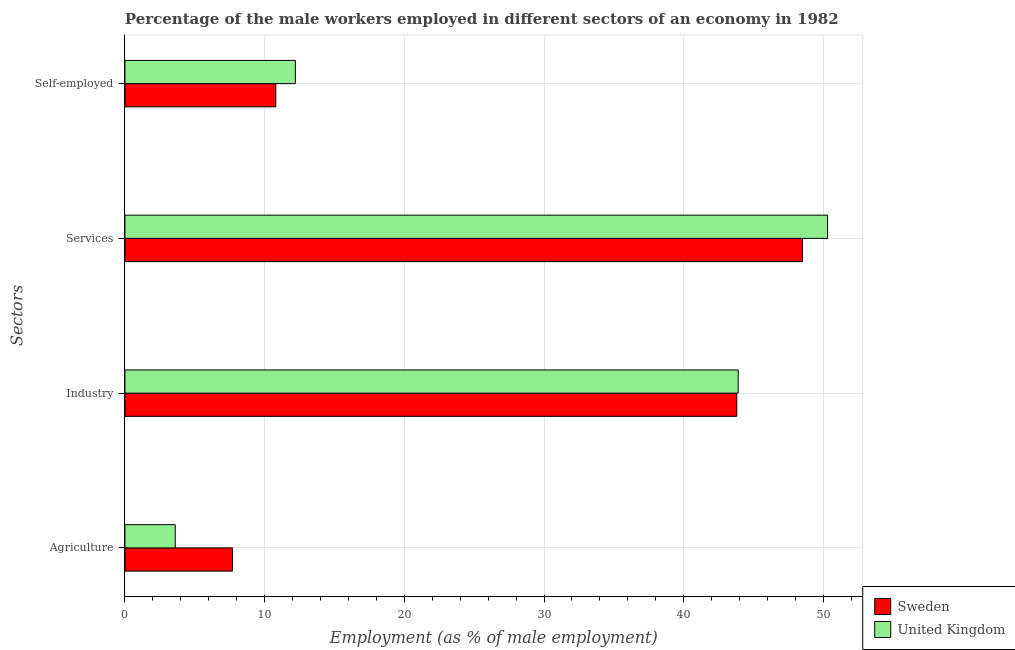How many different coloured bars are there?
Provide a short and direct response. 2. Are the number of bars per tick equal to the number of legend labels?
Your answer should be compact. Yes. Are the number of bars on each tick of the Y-axis equal?
Your answer should be compact. Yes. How many bars are there on the 4th tick from the top?
Provide a succinct answer. 2. What is the label of the 4th group of bars from the top?
Make the answer very short. Agriculture. What is the percentage of self employed male workers in Sweden?
Provide a short and direct response. 10.8. Across all countries, what is the maximum percentage of male workers in services?
Your answer should be very brief. 50.3. Across all countries, what is the minimum percentage of male workers in agriculture?
Offer a very short reply. 3.6. In which country was the percentage of male workers in services minimum?
Your answer should be compact. Sweden. What is the total percentage of self employed male workers in the graph?
Provide a short and direct response. 23. What is the difference between the percentage of self employed male workers in United Kingdom and that in Sweden?
Make the answer very short. 1.4. What is the difference between the percentage of self employed male workers in United Kingdom and the percentage of male workers in agriculture in Sweden?
Your answer should be very brief. 4.5. What is the average percentage of male workers in agriculture per country?
Make the answer very short. 5.65. What is the difference between the percentage of male workers in industry and percentage of self employed male workers in Sweden?
Offer a terse response. 33. In how many countries, is the percentage of male workers in industry greater than 26 %?
Keep it short and to the point. 2. What is the ratio of the percentage of male workers in industry in United Kingdom to that in Sweden?
Give a very brief answer. 1. Is the difference between the percentage of male workers in industry in United Kingdom and Sweden greater than the difference between the percentage of self employed male workers in United Kingdom and Sweden?
Ensure brevity in your answer.  No. What is the difference between the highest and the second highest percentage of male workers in services?
Provide a short and direct response. 1.8. What is the difference between the highest and the lowest percentage of male workers in industry?
Ensure brevity in your answer.  0.1. In how many countries, is the percentage of male workers in industry greater than the average percentage of male workers in industry taken over all countries?
Your answer should be compact. 1. What does the 1st bar from the top in Agriculture represents?
Offer a terse response. United Kingdom. What does the 2nd bar from the bottom in Agriculture represents?
Your answer should be very brief. United Kingdom. Is it the case that in every country, the sum of the percentage of male workers in agriculture and percentage of male workers in industry is greater than the percentage of male workers in services?
Your response must be concise. No. Are all the bars in the graph horizontal?
Offer a terse response. Yes. Are the values on the major ticks of X-axis written in scientific E-notation?
Offer a terse response. No. Does the graph contain any zero values?
Your answer should be compact. No. Does the graph contain grids?
Provide a succinct answer. Yes. What is the title of the graph?
Provide a succinct answer. Percentage of the male workers employed in different sectors of an economy in 1982. What is the label or title of the X-axis?
Your answer should be compact. Employment (as % of male employment). What is the label or title of the Y-axis?
Provide a short and direct response. Sectors. What is the Employment (as % of male employment) of Sweden in Agriculture?
Your answer should be compact. 7.7. What is the Employment (as % of male employment) of United Kingdom in Agriculture?
Make the answer very short. 3.6. What is the Employment (as % of male employment) of Sweden in Industry?
Ensure brevity in your answer.  43.8. What is the Employment (as % of male employment) in United Kingdom in Industry?
Offer a very short reply. 43.9. What is the Employment (as % of male employment) in Sweden in Services?
Provide a short and direct response. 48.5. What is the Employment (as % of male employment) in United Kingdom in Services?
Your answer should be compact. 50.3. What is the Employment (as % of male employment) in Sweden in Self-employed?
Offer a very short reply. 10.8. What is the Employment (as % of male employment) in United Kingdom in Self-employed?
Make the answer very short. 12.2. Across all Sectors, what is the maximum Employment (as % of male employment) in Sweden?
Make the answer very short. 48.5. Across all Sectors, what is the maximum Employment (as % of male employment) in United Kingdom?
Make the answer very short. 50.3. Across all Sectors, what is the minimum Employment (as % of male employment) in Sweden?
Provide a short and direct response. 7.7. Across all Sectors, what is the minimum Employment (as % of male employment) of United Kingdom?
Your answer should be very brief. 3.6. What is the total Employment (as % of male employment) in Sweden in the graph?
Make the answer very short. 110.8. What is the total Employment (as % of male employment) in United Kingdom in the graph?
Ensure brevity in your answer.  110. What is the difference between the Employment (as % of male employment) of Sweden in Agriculture and that in Industry?
Your answer should be very brief. -36.1. What is the difference between the Employment (as % of male employment) of United Kingdom in Agriculture and that in Industry?
Your response must be concise. -40.3. What is the difference between the Employment (as % of male employment) of Sweden in Agriculture and that in Services?
Your response must be concise. -40.8. What is the difference between the Employment (as % of male employment) in United Kingdom in Agriculture and that in Services?
Your answer should be compact. -46.7. What is the difference between the Employment (as % of male employment) in Sweden in Agriculture and that in Self-employed?
Your response must be concise. -3.1. What is the difference between the Employment (as % of male employment) in Sweden in Industry and that in Self-employed?
Offer a terse response. 33. What is the difference between the Employment (as % of male employment) in United Kingdom in Industry and that in Self-employed?
Keep it short and to the point. 31.7. What is the difference between the Employment (as % of male employment) in Sweden in Services and that in Self-employed?
Offer a very short reply. 37.7. What is the difference between the Employment (as % of male employment) in United Kingdom in Services and that in Self-employed?
Provide a short and direct response. 38.1. What is the difference between the Employment (as % of male employment) of Sweden in Agriculture and the Employment (as % of male employment) of United Kingdom in Industry?
Keep it short and to the point. -36.2. What is the difference between the Employment (as % of male employment) of Sweden in Agriculture and the Employment (as % of male employment) of United Kingdom in Services?
Your response must be concise. -42.6. What is the difference between the Employment (as % of male employment) of Sweden in Industry and the Employment (as % of male employment) of United Kingdom in Services?
Ensure brevity in your answer.  -6.5. What is the difference between the Employment (as % of male employment) of Sweden in Industry and the Employment (as % of male employment) of United Kingdom in Self-employed?
Offer a very short reply. 31.6. What is the difference between the Employment (as % of male employment) in Sweden in Services and the Employment (as % of male employment) in United Kingdom in Self-employed?
Offer a very short reply. 36.3. What is the average Employment (as % of male employment) in Sweden per Sectors?
Provide a short and direct response. 27.7. What is the average Employment (as % of male employment) in United Kingdom per Sectors?
Offer a terse response. 27.5. What is the difference between the Employment (as % of male employment) in Sweden and Employment (as % of male employment) in United Kingdom in Services?
Offer a very short reply. -1.8. What is the difference between the Employment (as % of male employment) of Sweden and Employment (as % of male employment) of United Kingdom in Self-employed?
Keep it short and to the point. -1.4. What is the ratio of the Employment (as % of male employment) in Sweden in Agriculture to that in Industry?
Ensure brevity in your answer.  0.18. What is the ratio of the Employment (as % of male employment) of United Kingdom in Agriculture to that in Industry?
Give a very brief answer. 0.08. What is the ratio of the Employment (as % of male employment) in Sweden in Agriculture to that in Services?
Offer a terse response. 0.16. What is the ratio of the Employment (as % of male employment) in United Kingdom in Agriculture to that in Services?
Your response must be concise. 0.07. What is the ratio of the Employment (as % of male employment) in Sweden in Agriculture to that in Self-employed?
Offer a very short reply. 0.71. What is the ratio of the Employment (as % of male employment) of United Kingdom in Agriculture to that in Self-employed?
Your answer should be compact. 0.3. What is the ratio of the Employment (as % of male employment) in Sweden in Industry to that in Services?
Offer a very short reply. 0.9. What is the ratio of the Employment (as % of male employment) of United Kingdom in Industry to that in Services?
Ensure brevity in your answer.  0.87. What is the ratio of the Employment (as % of male employment) of Sweden in Industry to that in Self-employed?
Provide a succinct answer. 4.06. What is the ratio of the Employment (as % of male employment) in United Kingdom in Industry to that in Self-employed?
Provide a short and direct response. 3.6. What is the ratio of the Employment (as % of male employment) of Sweden in Services to that in Self-employed?
Offer a terse response. 4.49. What is the ratio of the Employment (as % of male employment) of United Kingdom in Services to that in Self-employed?
Your answer should be very brief. 4.12. What is the difference between the highest and the second highest Employment (as % of male employment) in Sweden?
Your answer should be very brief. 4.7. What is the difference between the highest and the lowest Employment (as % of male employment) in Sweden?
Your answer should be very brief. 40.8. What is the difference between the highest and the lowest Employment (as % of male employment) in United Kingdom?
Make the answer very short. 46.7. 